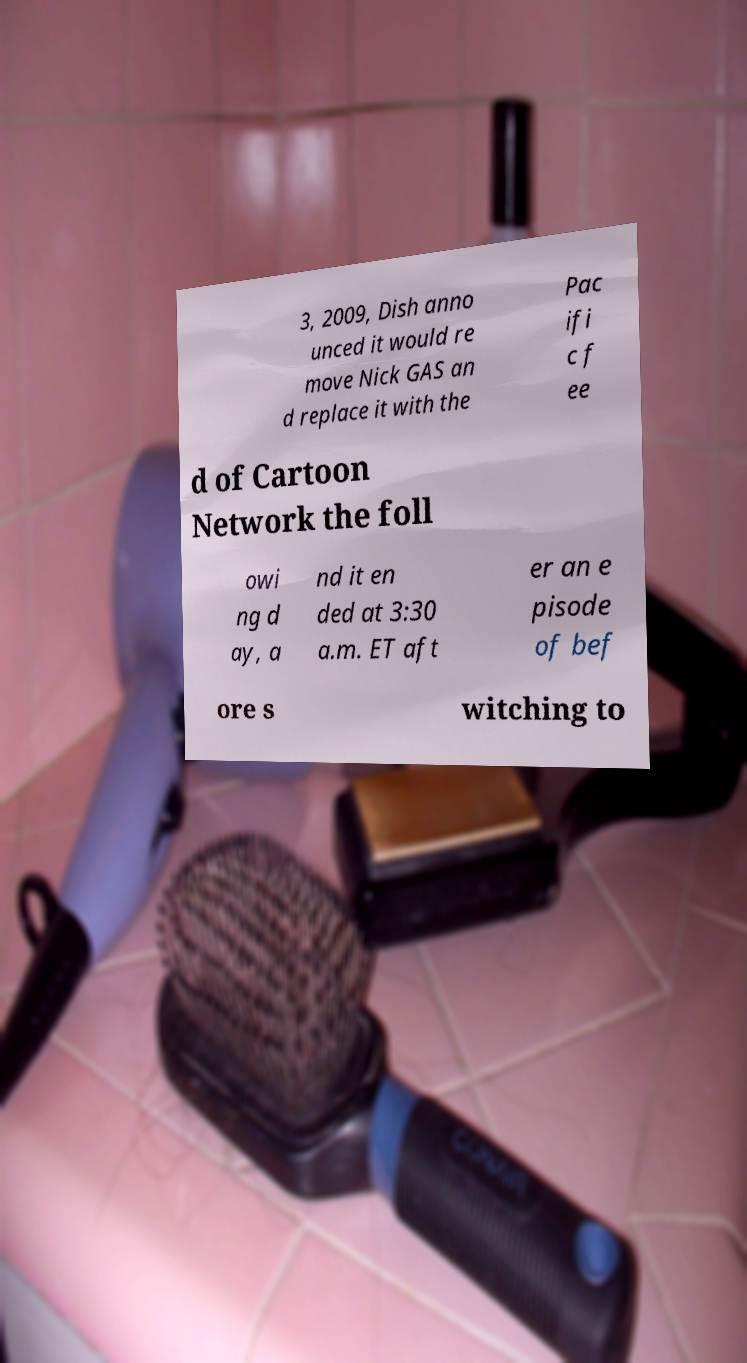There's text embedded in this image that I need extracted. Can you transcribe it verbatim? 3, 2009, Dish anno unced it would re move Nick GAS an d replace it with the Pac ifi c f ee d of Cartoon Network the foll owi ng d ay, a nd it en ded at 3:30 a.m. ET aft er an e pisode of bef ore s witching to 